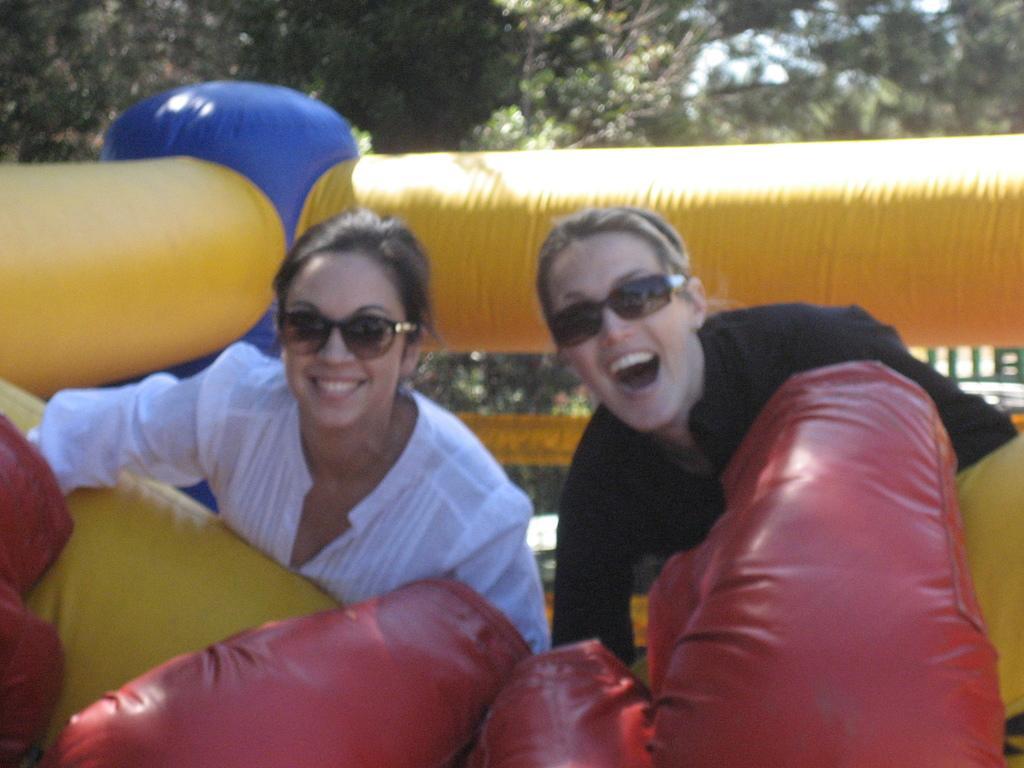Can you describe this image briefly? In this picture we can see two persons smiling, these two persons wore goggles, we can see an inflatable in the front, in the background there are some trees. 